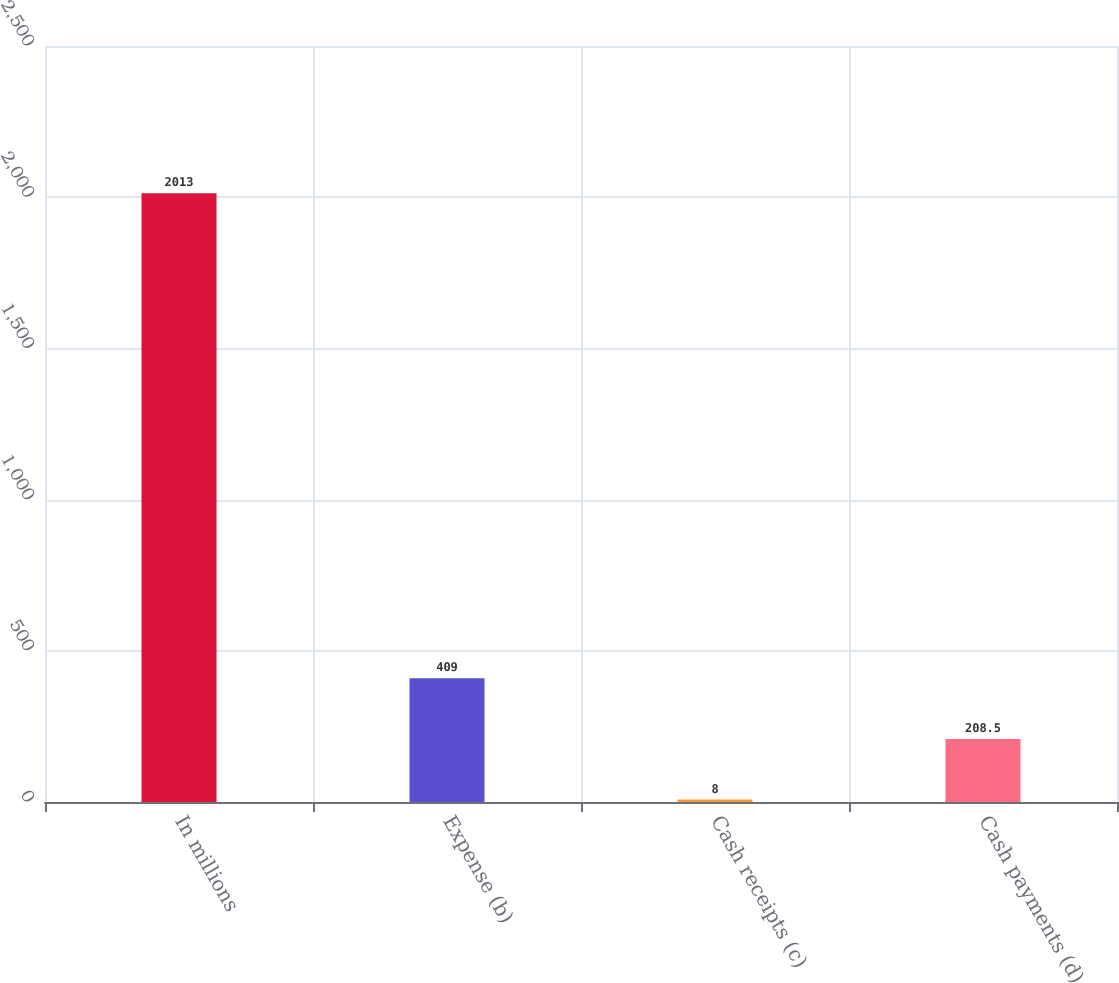<chart> <loc_0><loc_0><loc_500><loc_500><bar_chart><fcel>In millions<fcel>Expense (b)<fcel>Cash receipts (c)<fcel>Cash payments (d)<nl><fcel>2013<fcel>409<fcel>8<fcel>208.5<nl></chart> 